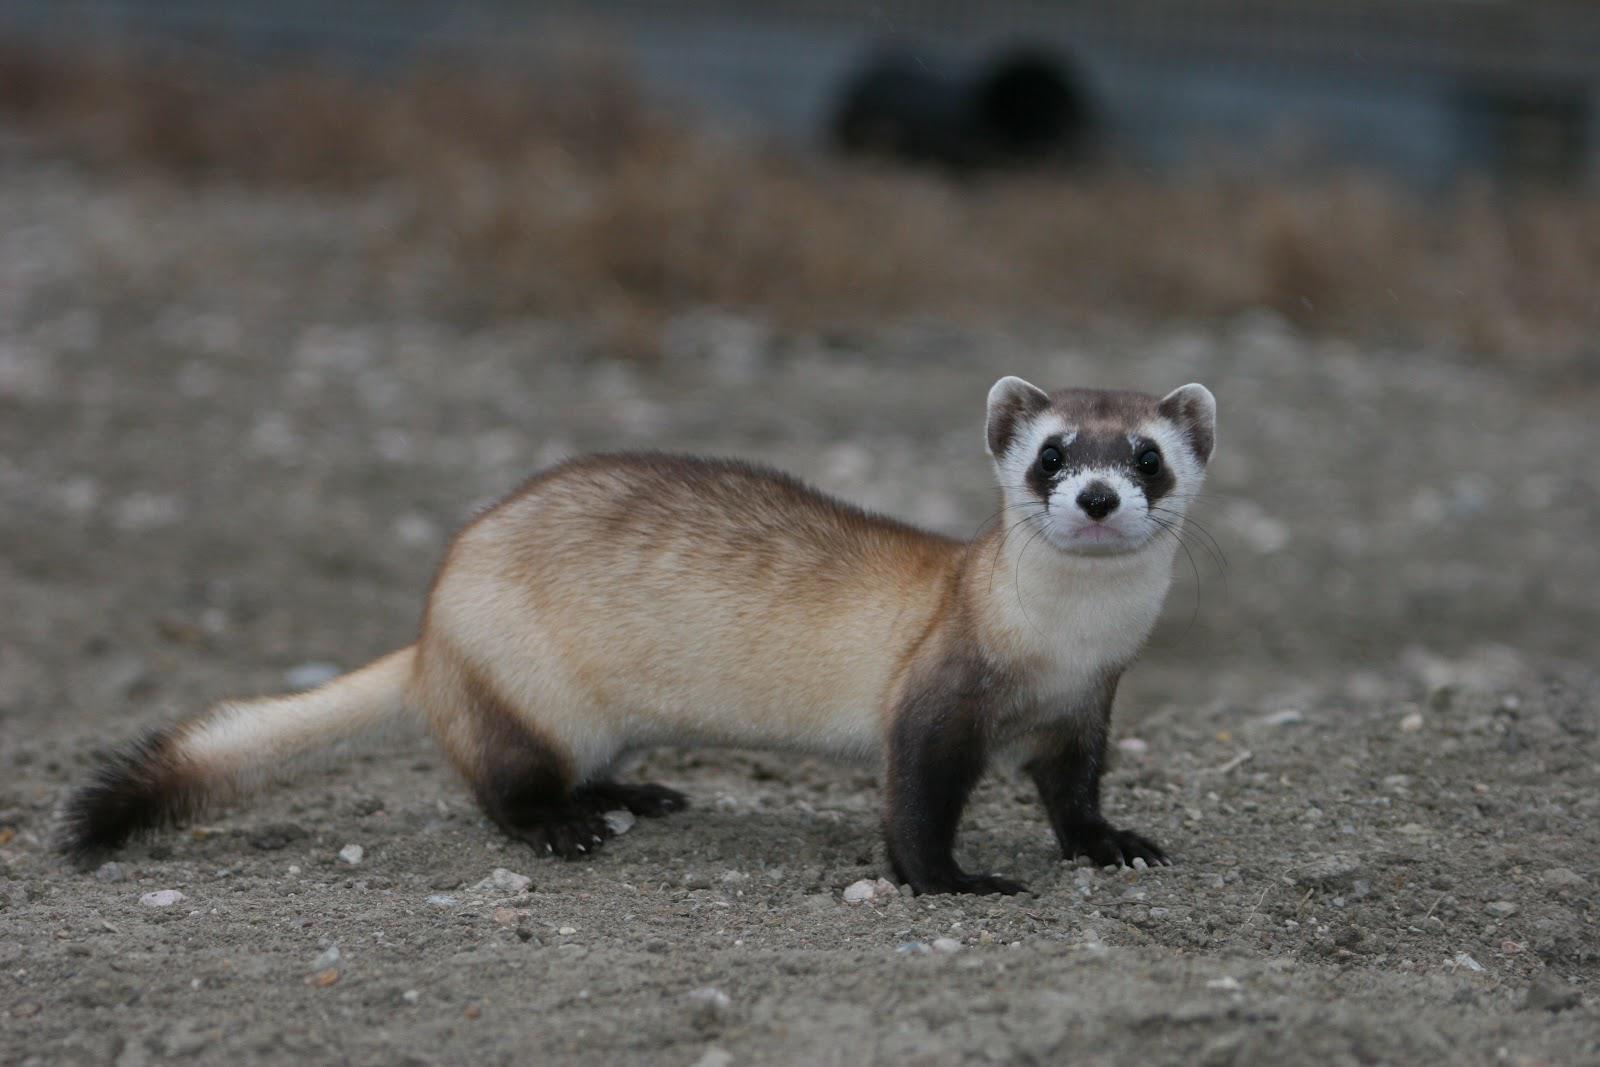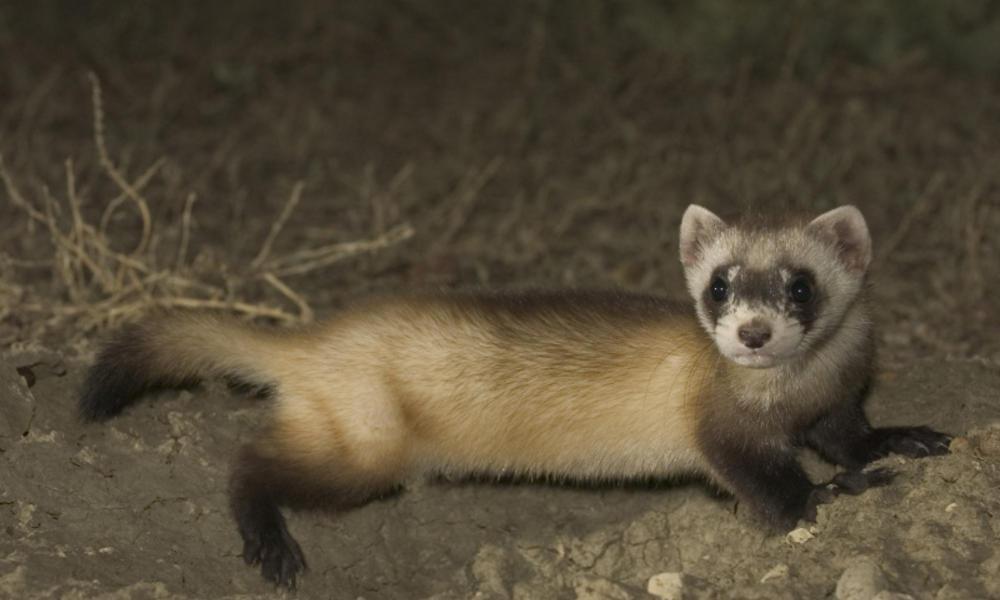The first image is the image on the left, the second image is the image on the right. Evaluate the accuracy of this statement regarding the images: "There Is a single brown and white small rodent facing left with black nose.". Is it true? Answer yes or no. No. 